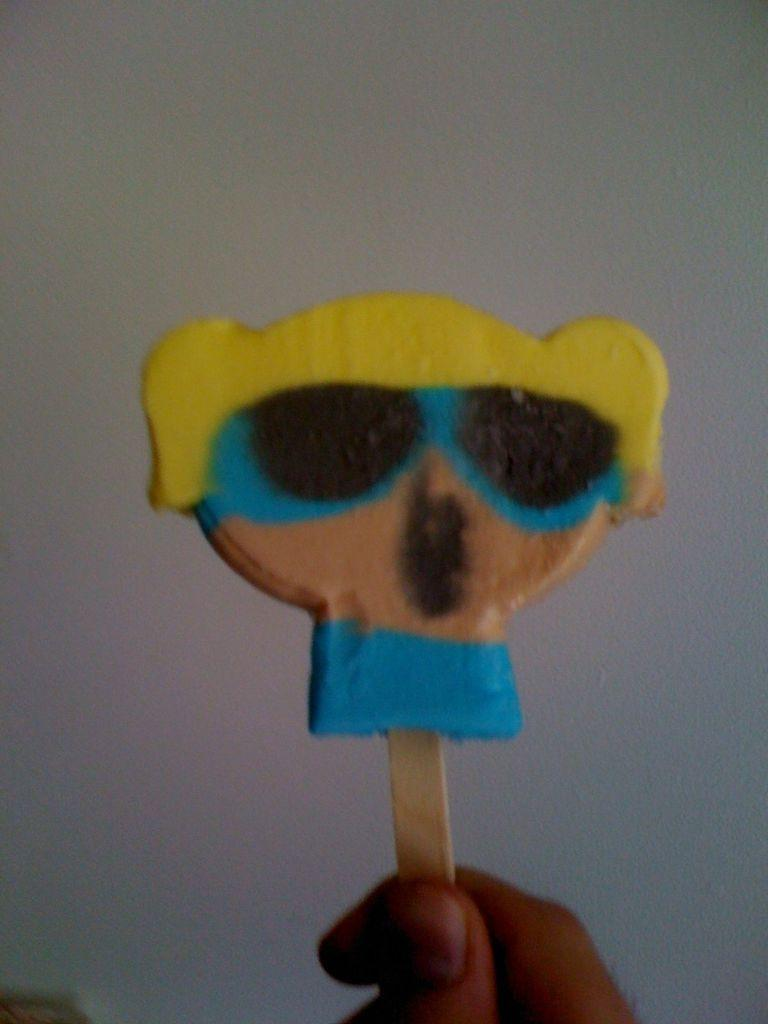What can be seen in the image? There is a human hand in the image. What is the hand holding? The hand is holding an eraser. Can you describe the eraser? The eraser is in the shape of a cartoon girl. Is there a kettle visible in the image? No, there is no kettle present in the image. 